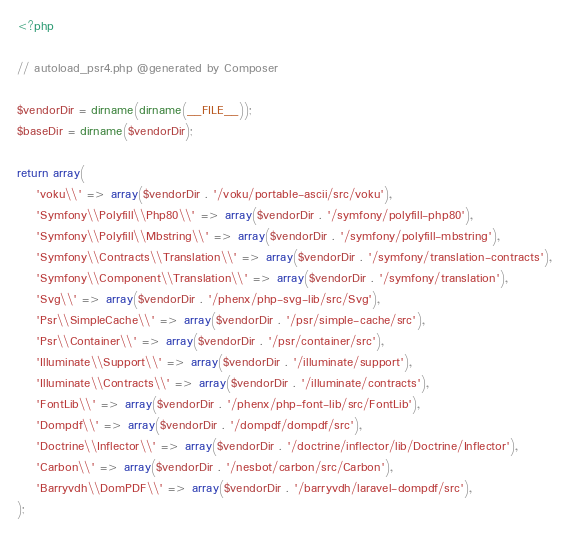<code> <loc_0><loc_0><loc_500><loc_500><_PHP_><?php

// autoload_psr4.php @generated by Composer

$vendorDir = dirname(dirname(__FILE__));
$baseDir = dirname($vendorDir);

return array(
    'voku\\' => array($vendorDir . '/voku/portable-ascii/src/voku'),
    'Symfony\\Polyfill\\Php80\\' => array($vendorDir . '/symfony/polyfill-php80'),
    'Symfony\\Polyfill\\Mbstring\\' => array($vendorDir . '/symfony/polyfill-mbstring'),
    'Symfony\\Contracts\\Translation\\' => array($vendorDir . '/symfony/translation-contracts'),
    'Symfony\\Component\\Translation\\' => array($vendorDir . '/symfony/translation'),
    'Svg\\' => array($vendorDir . '/phenx/php-svg-lib/src/Svg'),
    'Psr\\SimpleCache\\' => array($vendorDir . '/psr/simple-cache/src'),
    'Psr\\Container\\' => array($vendorDir . '/psr/container/src'),
    'Illuminate\\Support\\' => array($vendorDir . '/illuminate/support'),
    'Illuminate\\Contracts\\' => array($vendorDir . '/illuminate/contracts'),
    'FontLib\\' => array($vendorDir . '/phenx/php-font-lib/src/FontLib'),
    'Dompdf\\' => array($vendorDir . '/dompdf/dompdf/src'),
    'Doctrine\\Inflector\\' => array($vendorDir . '/doctrine/inflector/lib/Doctrine/Inflector'),
    'Carbon\\' => array($vendorDir . '/nesbot/carbon/src/Carbon'),
    'Barryvdh\\DomPDF\\' => array($vendorDir . '/barryvdh/laravel-dompdf/src'),
);
</code> 